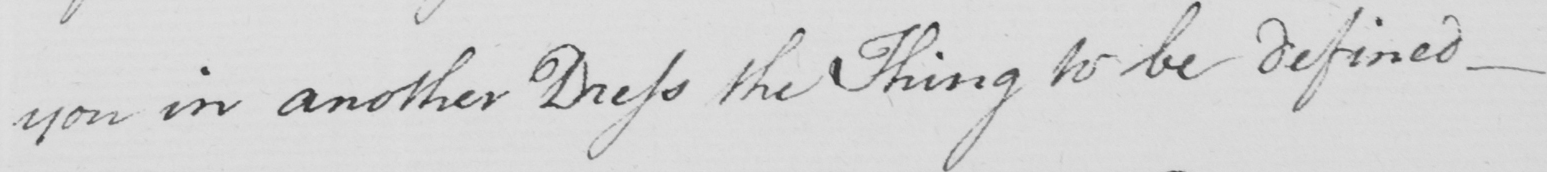Transcribe the text shown in this historical manuscript line. you in another Dress the Thing to be defined  _ 